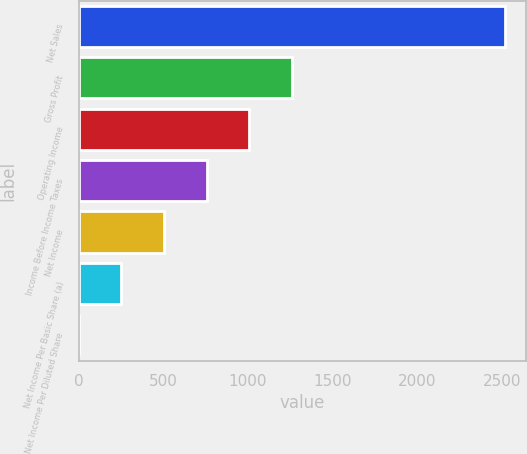Convert chart to OTSL. <chart><loc_0><loc_0><loc_500><loc_500><bar_chart><fcel>Net Sales<fcel>Gross Profit<fcel>Operating Income<fcel>Income Before Income Taxes<fcel>Net Income<fcel>Net Income Per Basic Share (a)<fcel>Net Income Per Diluted Share<nl><fcel>2516<fcel>1258.31<fcel>1006.77<fcel>755.23<fcel>503.69<fcel>252.15<fcel>0.61<nl></chart> 